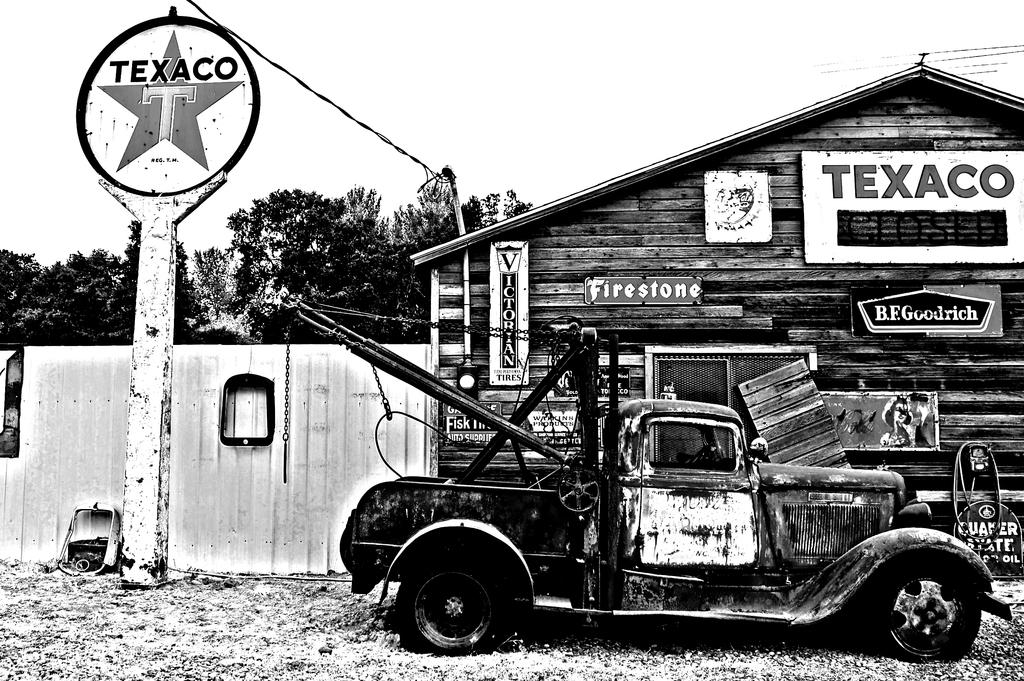What is the main subject in the picture? There is a vehicle in the picture. What type of structure can be seen in the picture? There is a wooden house in the picture. Can you describe any text or symbols on the wooden house? Something is written on the wooden house. What is located in the left corner of the picture? There is a pole in the left corner of the picture. What can be seen in the background of the picture? There are trees in the background of the picture. What type of unit is being discovered in the image? There is no mention of a unit or discovery in the image; it features a vehicle, a wooden house, a pole, and trees. What type of net is being used in the image? There is no net present in the image. 